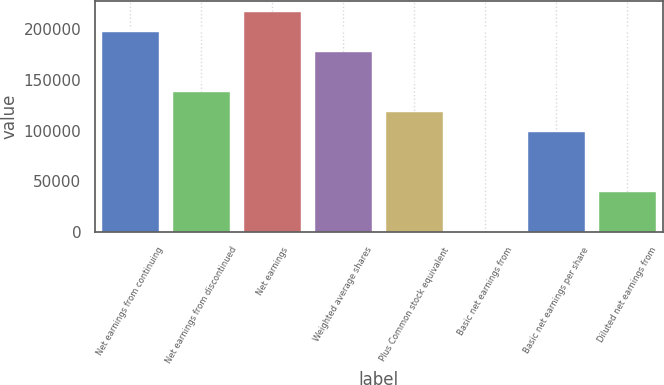Convert chart to OTSL. <chart><loc_0><loc_0><loc_500><loc_500><bar_chart><fcel>Net earnings from continuing<fcel>Net earnings from discontinued<fcel>Net earnings<fcel>Weighted average shares<fcel>Plus Common stock equivalent<fcel>Basic net earnings from<fcel>Basic net earnings per share<fcel>Diluted net earnings from<nl><fcel>196550<fcel>137585<fcel>216205<fcel>176895<fcel>117930<fcel>0.12<fcel>98275.1<fcel>39310.1<nl></chart> 